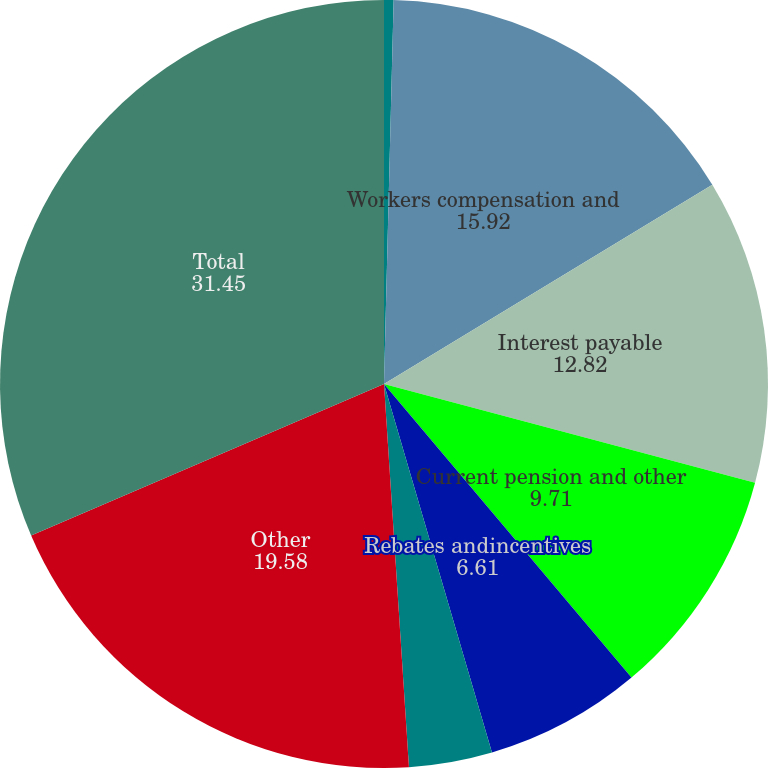Convert chart to OTSL. <chart><loc_0><loc_0><loc_500><loc_500><pie_chart><fcel>(DOLLARS IN THOUSANDS)<fcel>Workers compensation and<fcel>Interest payable<fcel>Current pension and other<fcel>Rebates andincentives<fcel>Commissions and<fcel>Other<fcel>Total<nl><fcel>0.4%<fcel>15.92%<fcel>12.82%<fcel>9.71%<fcel>6.61%<fcel>3.5%<fcel>19.58%<fcel>31.45%<nl></chart> 